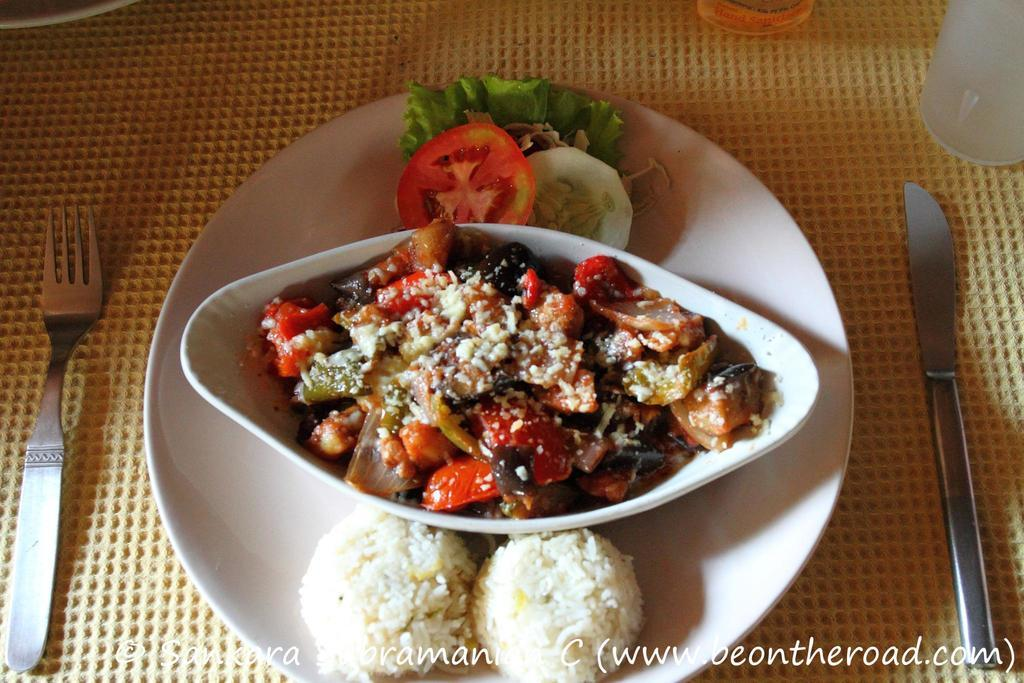What is in the center of the image? There is a plate with food items in the center of the image. What utensils are present in the image? There is a fork, a spoon, and a knife in the image. Is there any text in the image? Yes, there is text at the bottom of the image. What type of collar can be seen on the pies in the image? There are no pies present in the image, and therefore no collars can be seen on them. 